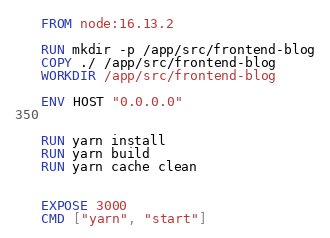<code> <loc_0><loc_0><loc_500><loc_500><_Dockerfile_>FROM node:16.13.2

RUN mkdir -p /app/src/frontend-blog
COPY ./ /app/src/frontend-blog
WORKDIR /app/src/frontend-blog

ENV HOST "0.0.0.0"


RUN yarn install
RUN yarn build
RUN yarn cache clean


EXPOSE 3000
CMD ["yarn", "start"]</code> 